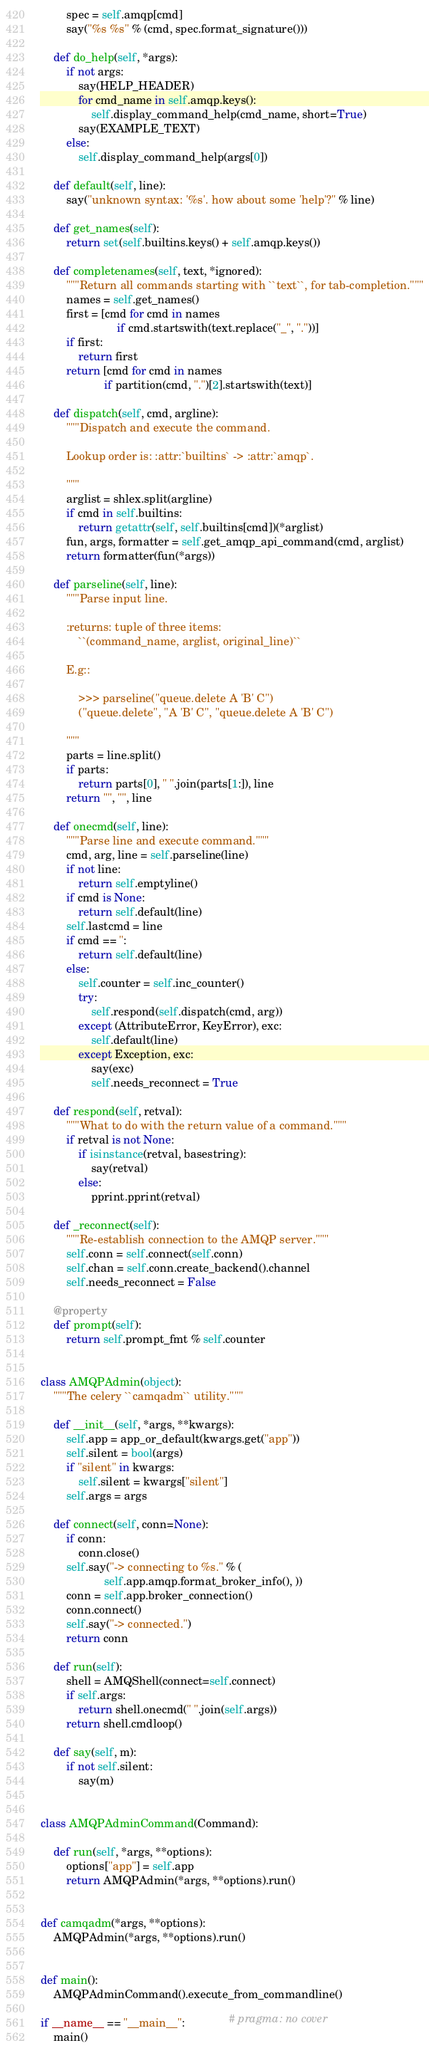Convert code to text. <code><loc_0><loc_0><loc_500><loc_500><_Python_>        spec = self.amqp[cmd]
        say("%s %s" % (cmd, spec.format_signature()))

    def do_help(self, *args):
        if not args:
            say(HELP_HEADER)
            for cmd_name in self.amqp.keys():
                self.display_command_help(cmd_name, short=True)
            say(EXAMPLE_TEXT)
        else:
            self.display_command_help(args[0])

    def default(self, line):
        say("unknown syntax: '%s'. how about some 'help'?" % line)

    def get_names(self):
        return set(self.builtins.keys() + self.amqp.keys())

    def completenames(self, text, *ignored):
        """Return all commands starting with ``text``, for tab-completion."""
        names = self.get_names()
        first = [cmd for cmd in names
                        if cmd.startswith(text.replace("_", "."))]
        if first:
            return first
        return [cmd for cmd in names
                    if partition(cmd, ".")[2].startswith(text)]

    def dispatch(self, cmd, argline):
        """Dispatch and execute the command.

        Lookup order is: :attr:`builtins` -> :attr:`amqp`.

        """
        arglist = shlex.split(argline)
        if cmd in self.builtins:
            return getattr(self, self.builtins[cmd])(*arglist)
        fun, args, formatter = self.get_amqp_api_command(cmd, arglist)
        return formatter(fun(*args))

    def parseline(self, line):
        """Parse input line.

        :returns: tuple of three items:
            ``(command_name, arglist, original_line)``

        E.g::

            >>> parseline("queue.delete A 'B' C")
            ("queue.delete", "A 'B' C", "queue.delete A 'B' C")

        """
        parts = line.split()
        if parts:
            return parts[0], " ".join(parts[1:]), line
        return "", "", line

    def onecmd(self, line):
        """Parse line and execute command."""
        cmd, arg, line = self.parseline(line)
        if not line:
            return self.emptyline()
        if cmd is None:
            return self.default(line)
        self.lastcmd = line
        if cmd == '':
            return self.default(line)
        else:
            self.counter = self.inc_counter()
            try:
                self.respond(self.dispatch(cmd, arg))
            except (AttributeError, KeyError), exc:
                self.default(line)
            except Exception, exc:
                say(exc)
                self.needs_reconnect = True

    def respond(self, retval):
        """What to do with the return value of a command."""
        if retval is not None:
            if isinstance(retval, basestring):
                say(retval)
            else:
                pprint.pprint(retval)

    def _reconnect(self):
        """Re-establish connection to the AMQP server."""
        self.conn = self.connect(self.conn)
        self.chan = self.conn.create_backend().channel
        self.needs_reconnect = False

    @property
    def prompt(self):
        return self.prompt_fmt % self.counter


class AMQPAdmin(object):
    """The celery ``camqadm`` utility."""

    def __init__(self, *args, **kwargs):
        self.app = app_or_default(kwargs.get("app"))
        self.silent = bool(args)
        if "silent" in kwargs:
            self.silent = kwargs["silent"]
        self.args = args

    def connect(self, conn=None):
        if conn:
            conn.close()
        self.say("-> connecting to %s." % (
                    self.app.amqp.format_broker_info(), ))
        conn = self.app.broker_connection()
        conn.connect()
        self.say("-> connected.")
        return conn

    def run(self):
        shell = AMQShell(connect=self.connect)
        if self.args:
            return shell.onecmd(" ".join(self.args))
        return shell.cmdloop()

    def say(self, m):
        if not self.silent:
            say(m)


class AMQPAdminCommand(Command):

    def run(self, *args, **options):
        options["app"] = self.app
        return AMQPAdmin(*args, **options).run()


def camqadm(*args, **options):
    AMQPAdmin(*args, **options).run()


def main():
    AMQPAdminCommand().execute_from_commandline()

if __name__ == "__main__":              # pragma: no cover
    main()
</code> 